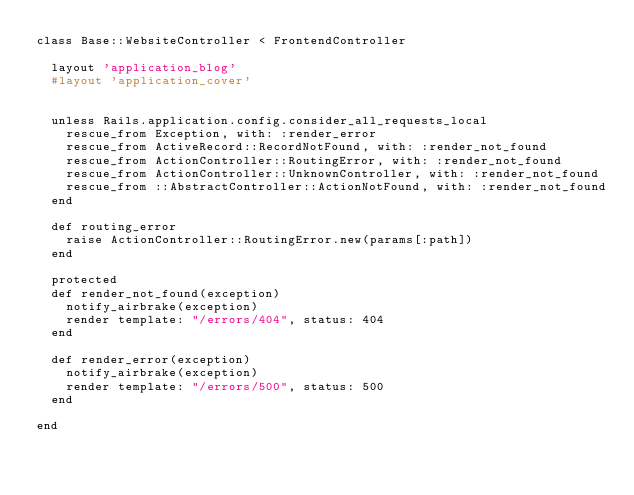<code> <loc_0><loc_0><loc_500><loc_500><_Ruby_>class Base::WebsiteController < FrontendController

  layout 'application_blog'
  #layout 'application_cover'


  unless Rails.application.config.consider_all_requests_local
    rescue_from Exception, with: :render_error
    rescue_from ActiveRecord::RecordNotFound, with: :render_not_found
    rescue_from ActionController::RoutingError, with: :render_not_found
    rescue_from ActionController::UnknownController, with: :render_not_found
    rescue_from ::AbstractController::ActionNotFound, with: :render_not_found
  end

  def routing_error
    raise ActionController::RoutingError.new(params[:path])
  end

  protected
  def render_not_found(exception)
    notify_airbrake(exception)
    render template: "/errors/404", status: 404
  end

  def render_error(exception)
    notify_airbrake(exception)
    render template: "/errors/500", status: 500
  end

end



</code> 